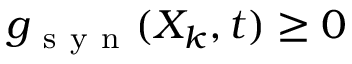<formula> <loc_0><loc_0><loc_500><loc_500>g _ { s y n } ( X _ { k } , t ) \geq 0</formula> 